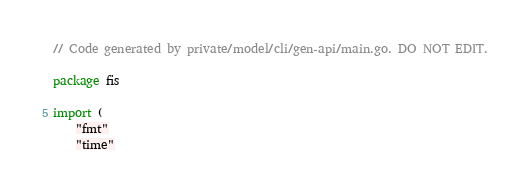<code> <loc_0><loc_0><loc_500><loc_500><_Go_>// Code generated by private/model/cli/gen-api/main.go. DO NOT EDIT.

package fis

import (
	"fmt"
	"time"
</code> 